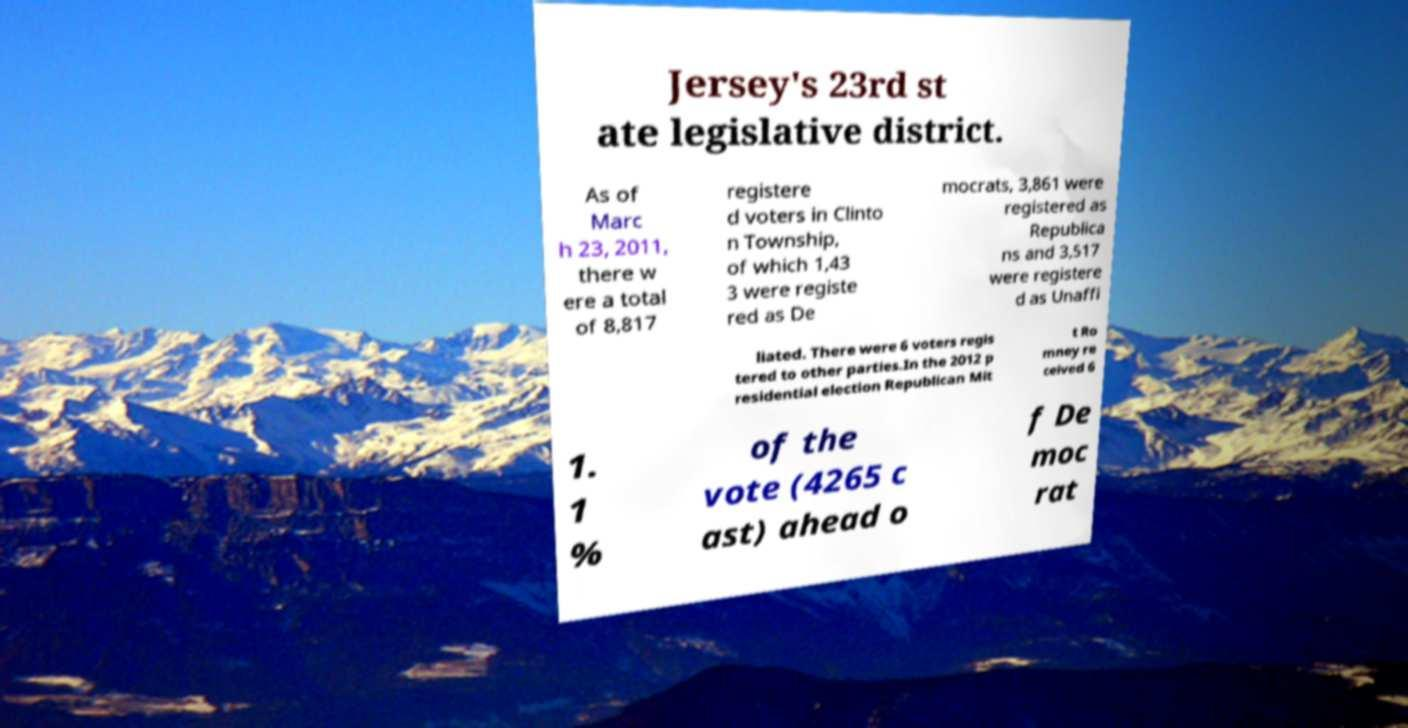For documentation purposes, I need the text within this image transcribed. Could you provide that? Jersey's 23rd st ate legislative district. As of Marc h 23, 2011, there w ere a total of 8,817 registere d voters in Clinto n Township, of which 1,43 3 were registe red as De mocrats, 3,861 were registered as Republica ns and 3,517 were registere d as Unaffi liated. There were 6 voters regis tered to other parties.In the 2012 p residential election Republican Mit t Ro mney re ceived 6 1. 1 % of the vote (4265 c ast) ahead o f De moc rat 